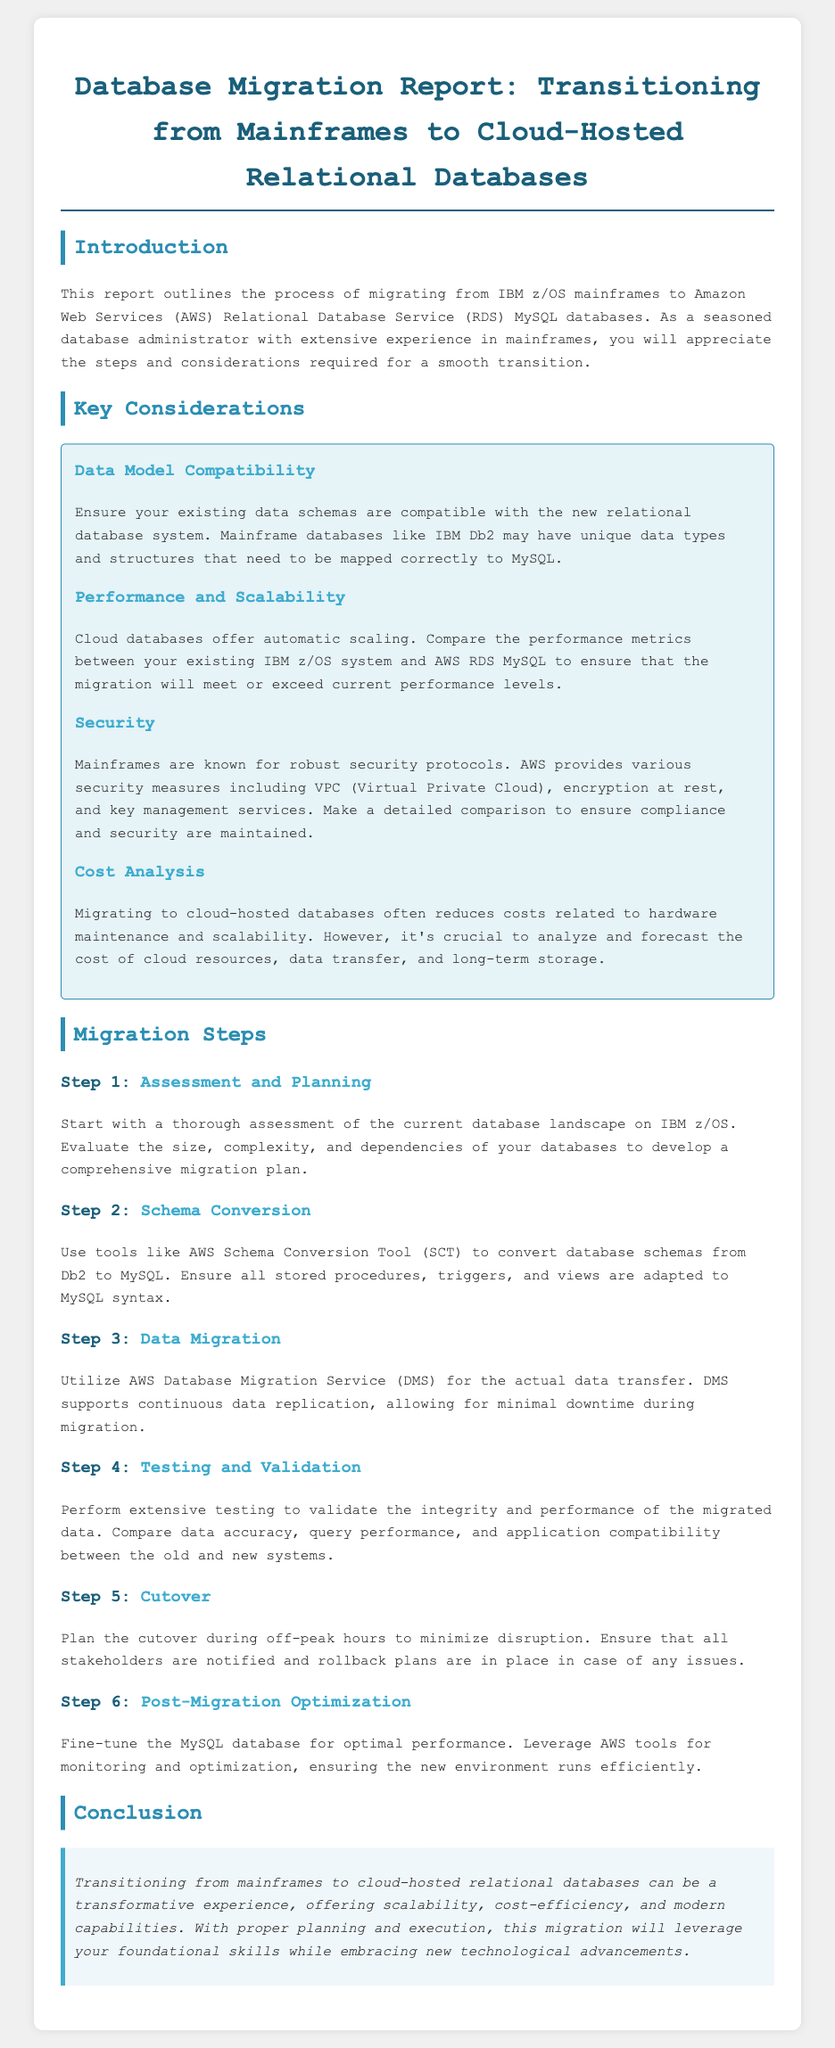what is the main focus of the report? The report outlines the process of migrating from IBM z/OS mainframes to AWS RDS MySQL databases.
Answer: migrating from IBM z/OS mainframes to AWS RDS MySQL databases what does AWS provide for security? The document mentions various security measures provided by AWS, including VPC, encryption at rest, and key management services.
Answer: VPC, encryption at rest, key management services how many migration steps are outlined in the report? The migration steps section contains six distinct steps outlined in the document.
Answer: six which tool is recommended for schema conversion? The report suggests using the AWS Schema Conversion Tool for converting database schemas.
Answer: AWS Schema Conversion Tool what is the expected benefit of moving to cloud-hosted databases? Benefits include reduced costs related to hardware maintenance and scalability.
Answer: reduced costs what should be compared during testing and validation? The testing should compare data accuracy, query performance, and application compatibility between the old and new systems.
Answer: data accuracy, query performance, application compatibility during which hours should the cutover be planned? Cutover should ideally be planned during off-peak hours to minimize disruption.
Answer: off-peak hours what is suggested for post-migration actions? The report suggests fine-tuning the MySQL database for optimal performance as a post-migration action.
Answer: fine-tune the MySQL database what is the concluding message of the report? The conclusion emphasizes that proper planning and execution can leverage foundational skills and embrace new technological advancements.
Answer: proper planning and execution can leverage foundational skills 